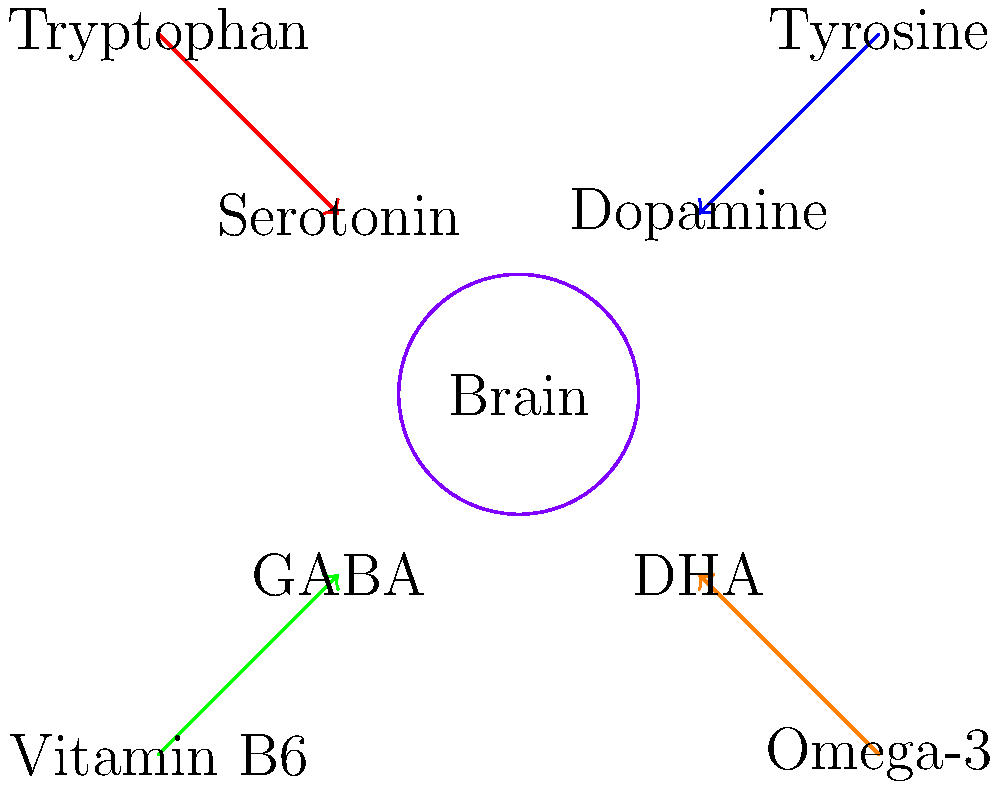Based on the diagram, which essential amino acid is a precursor for the neurotransmitter serotonin, and how does this relationship support the concept that diet influences mental health? 1. Observe the diagram: It shows various nutrients and their relationships to neurotransmitters in the brain.

2. Identify the precursor for serotonin: The diagram shows an arrow connecting "Tryptophan" to "Serotonin".

3. Understand the relationship: Tryptophan is an essential amino acid that serves as a precursor for serotonin production in the brain.

4. Link to mental health: Serotonin is a neurotransmitter associated with mood regulation, sleep, and overall well-being.

5. Connect to diet: Since tryptophan is an essential amino acid, it must be obtained through diet. Foods rich in tryptophan include turkey, eggs, cheese, nuts, seeds, and fish.

6. Explain the influence on mental health: Adequate dietary intake of tryptophan ensures the brain has sufficient raw material to produce serotonin, potentially improving mood and mental health.

7. Broader implications: This relationship exemplifies how specific nutrients from our diet directly influence the production of neurotransmitters, supporting the concept that diet plays a crucial role in mental health.
Answer: Tryptophan; dietary tryptophan enables serotonin production, influencing mood and mental well-being. 